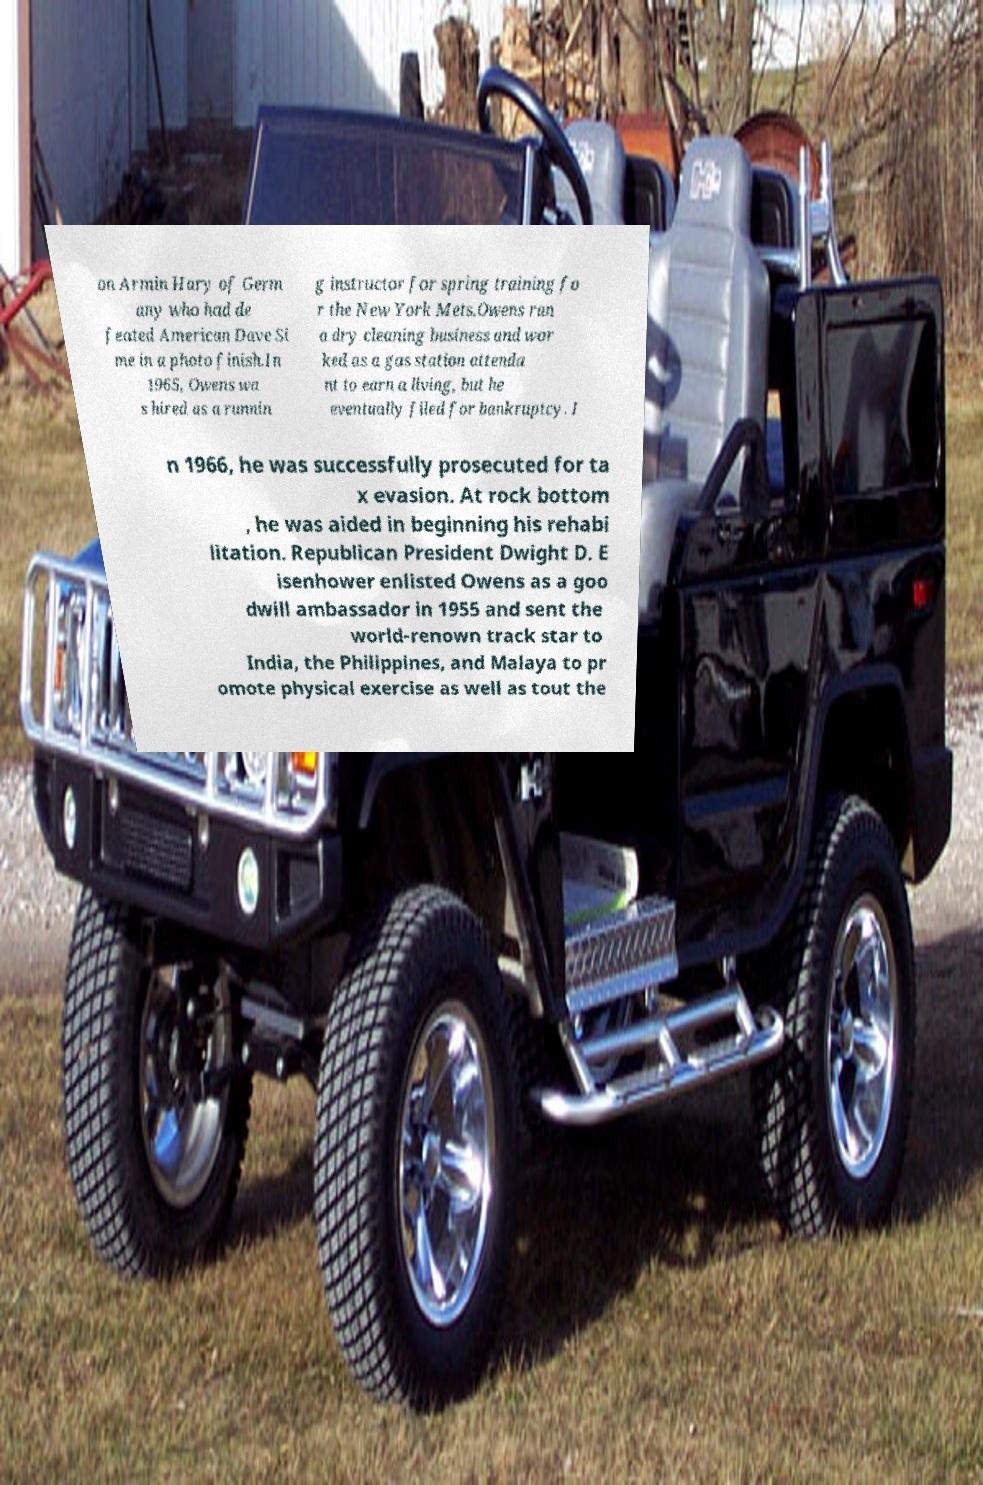I need the written content from this picture converted into text. Can you do that? on Armin Hary of Germ any who had de feated American Dave Si me in a photo finish.In 1965, Owens wa s hired as a runnin g instructor for spring training fo r the New York Mets.Owens ran a dry cleaning business and wor ked as a gas station attenda nt to earn a living, but he eventually filed for bankruptcy. I n 1966, he was successfully prosecuted for ta x evasion. At rock bottom , he was aided in beginning his rehabi litation. Republican President Dwight D. E isenhower enlisted Owens as a goo dwill ambassador in 1955 and sent the world-renown track star to India, the Philippines, and Malaya to pr omote physical exercise as well as tout the 